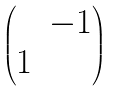Convert formula to latex. <formula><loc_0><loc_0><loc_500><loc_500>\begin{pmatrix} & - 1 \\ 1 & \end{pmatrix}</formula> 